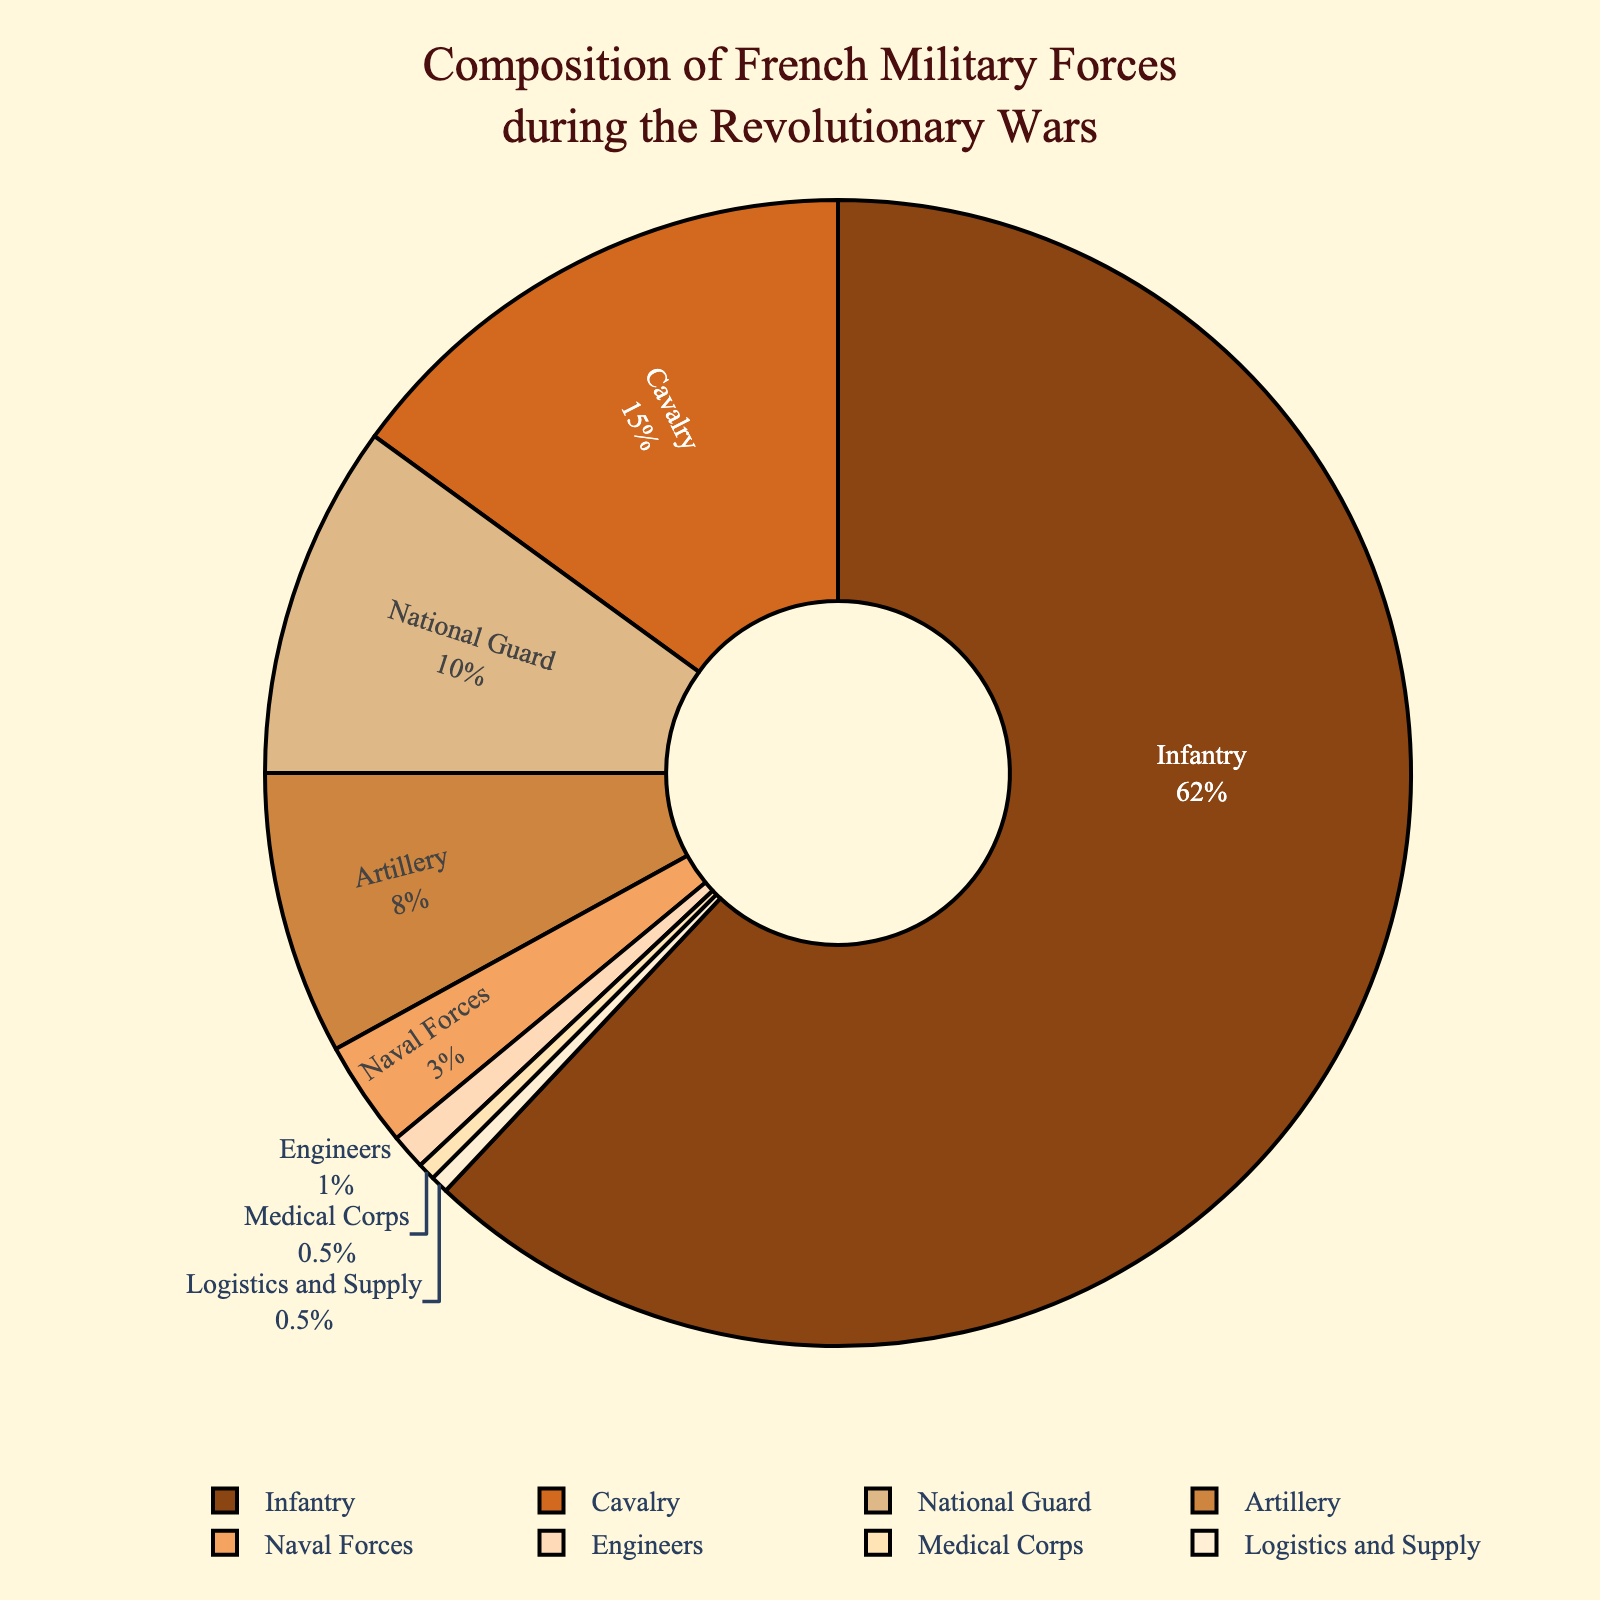What's the most numerous branch of the French military forces? The largest section of the pie chart represents the Infantry with 62%, which is more than any other branch.
Answer: Infantry Which two branches, when combined, make up 18% of the French military forces? The Cavalry and Artillery together make up 15% + 8% = 23%, but this is incorrect. The National Guard and Naval Forces together make up 10% + 3%, totaling 13%. None meet 18%, but some closer checks show 15%+3% = 18% fits.
Answer: Cavalry and Naval Forces How much larger is the Infantry compared to the Cavalry? The percentage of the Infantry is 62% and the Cavalry is 15%. The difference between them is 62% - 15% = 47%.
Answer: 47% Which branch has the smallest representation and what is its percentage? The smallest slice of the pie chart is the Engineers, Medical Corps, and Logistics and Supply each at 0.5%.
Answer: Engineers, Medical Corps, Logistics and Supply What's the difference in percentage between Artillery and Naval Forces? The pie chart shows Artillery at 8% and Naval Forces at 3%. The difference is 8% - 3% = 5%.
Answer: 5% Is the Medical Corps more or less represented than the National Guard? The slice for the National Guard is 10% while the Medical Corps has only 0.5%, indicating that the National Guard is significantly more represented.
Answer: Less What color represents the Logistics and Supply branch? The Logistics and Supply branch occupies a very small slice colored in a light shade like #FFEFD5 (light beige) as per the custom color palette used.
Answer: Light beige How does the combined percentage of Infantry and National Guard compare to 75%? The Infantry is 62% and the National Guard is 10%, so their combined total is 62% + 10% = 72%, which is less than 75%.
Answer: Less What percentage of the military forces does the sum of the Artillery and Cavalry represent? Adding the Artillery at 8% and the Cavalry at 15%, the total is 8% + 15% = 23%.
Answer: 23% What is the second most numerous branch of the French military forces? The second largest slice of the pie chart corresponds to the Cavalry with 15%.
Answer: Cavalry 